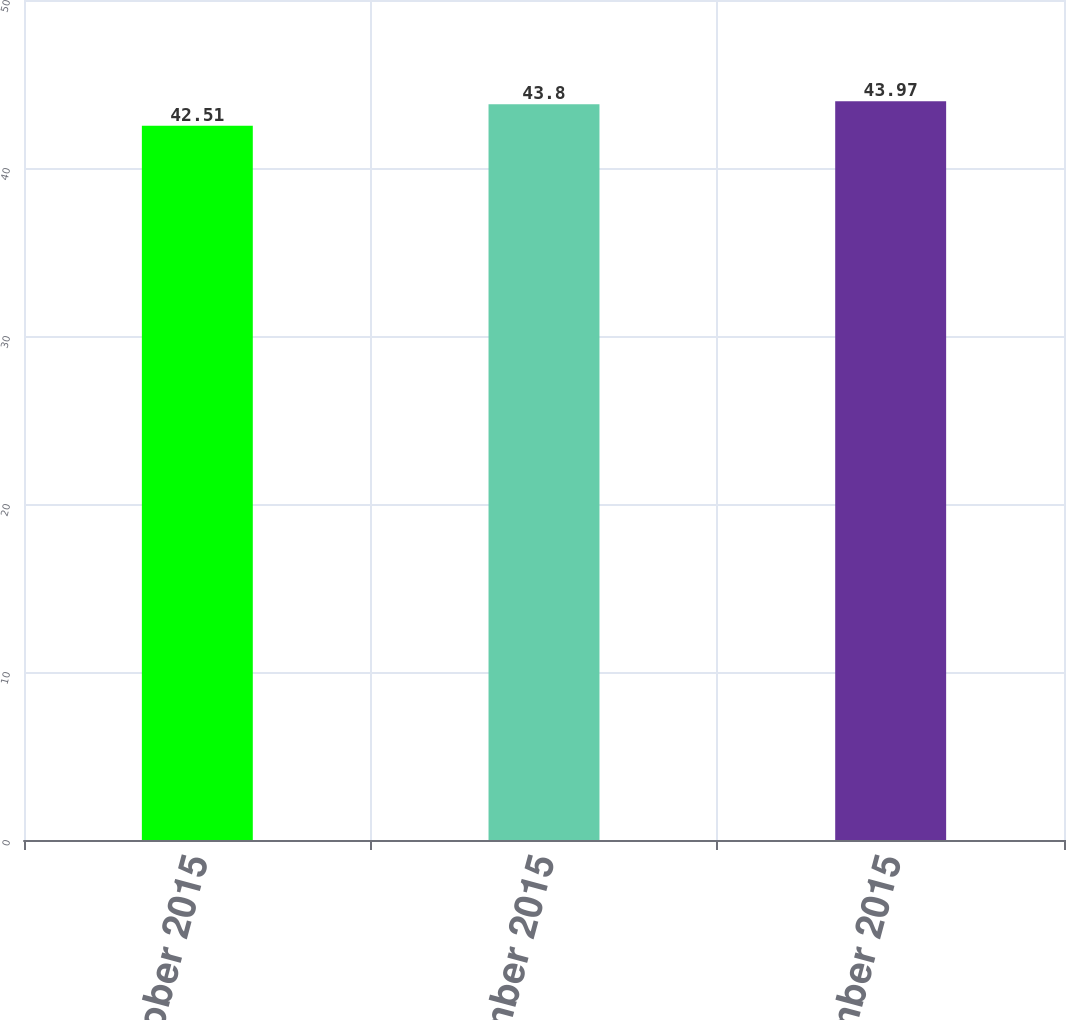Convert chart to OTSL. <chart><loc_0><loc_0><loc_500><loc_500><bar_chart><fcel>October 2015<fcel>November 2015<fcel>December 2015<nl><fcel>42.51<fcel>43.8<fcel>43.97<nl></chart> 